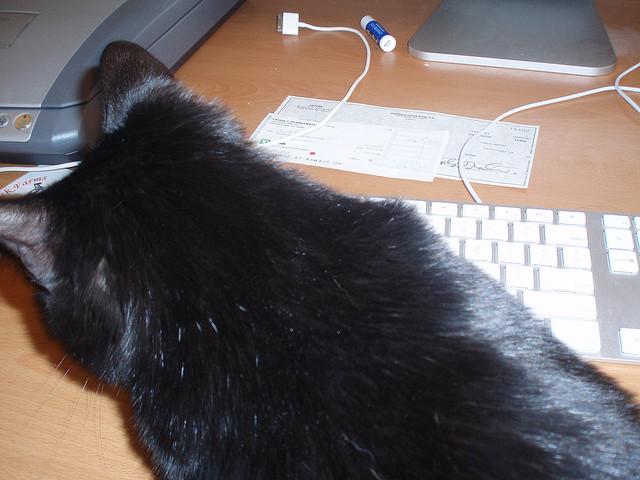What is that piece of paper behind the keyboard?
Short answer required. Check. What color is this cat?
Concise answer only. Black. Where is some chapstick?
Answer briefly. On desk. 